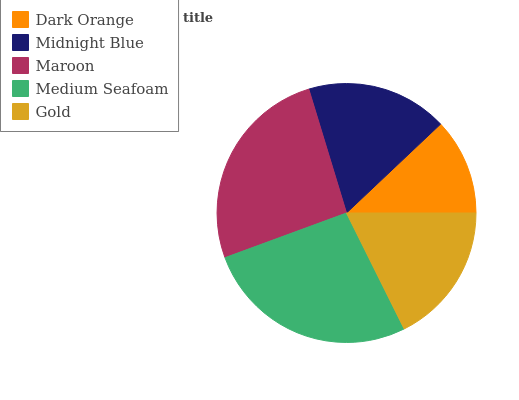Is Dark Orange the minimum?
Answer yes or no. Yes. Is Medium Seafoam the maximum?
Answer yes or no. Yes. Is Midnight Blue the minimum?
Answer yes or no. No. Is Midnight Blue the maximum?
Answer yes or no. No. Is Midnight Blue greater than Dark Orange?
Answer yes or no. Yes. Is Dark Orange less than Midnight Blue?
Answer yes or no. Yes. Is Dark Orange greater than Midnight Blue?
Answer yes or no. No. Is Midnight Blue less than Dark Orange?
Answer yes or no. No. Is Gold the high median?
Answer yes or no. Yes. Is Gold the low median?
Answer yes or no. Yes. Is Dark Orange the high median?
Answer yes or no. No. Is Medium Seafoam the low median?
Answer yes or no. No. 